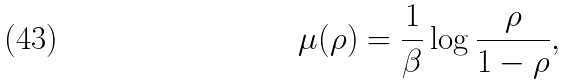<formula> <loc_0><loc_0><loc_500><loc_500>\mu ( \rho ) = \frac { 1 } { \beta } \log \frac { \rho } { 1 - \rho } ,</formula> 